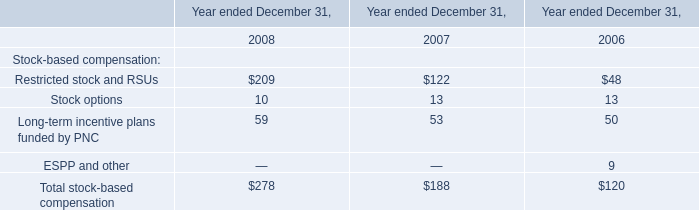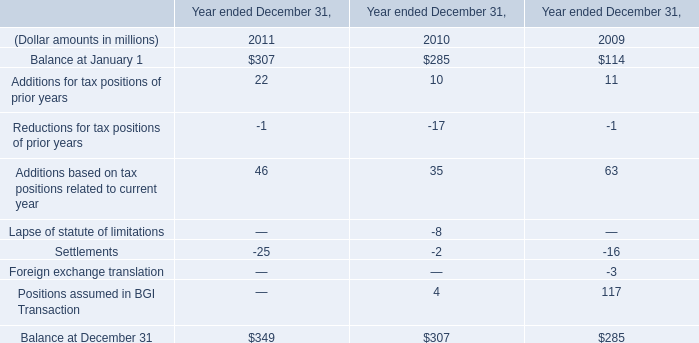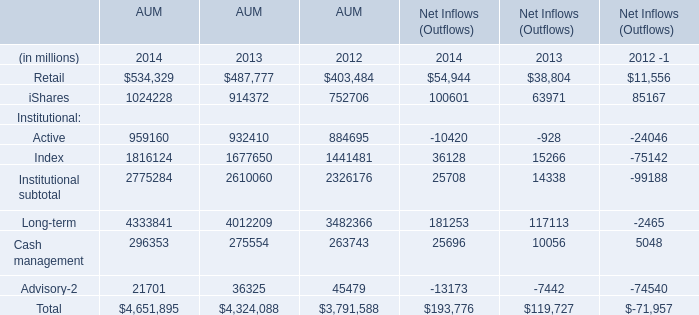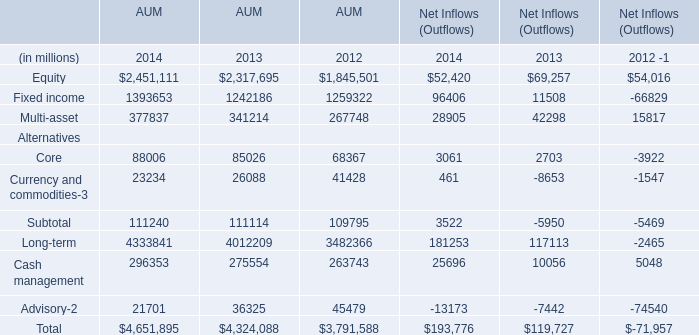What's the average of AUM Active and Index and Institutional subtotal in 2014? (in million) 
Computations: (((959160 + 1816124) + 2775284) / 3)
Answer: 1850189.33333. What's the sum of the Core AUM in the years where Long-term AUM is positive? (in millions) 
Computations: ((88006 + 85026) + 68367)
Answer: 241399.0. 